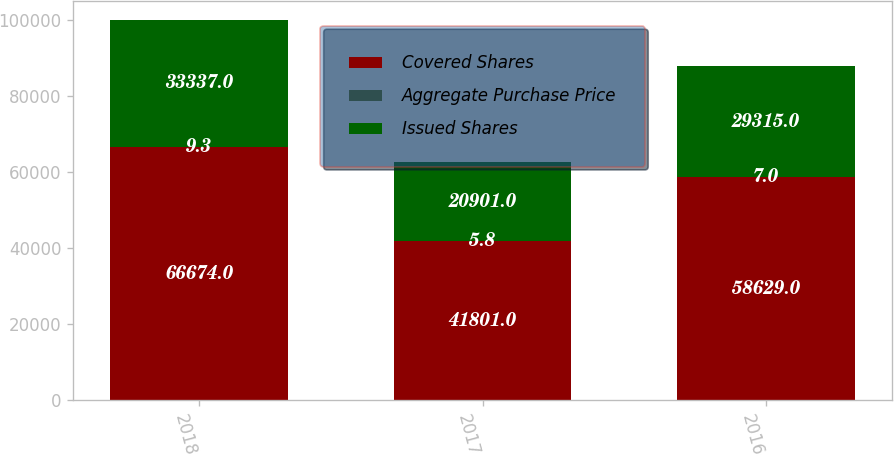Convert chart to OTSL. <chart><loc_0><loc_0><loc_500><loc_500><stacked_bar_chart><ecel><fcel>2018<fcel>2017<fcel>2016<nl><fcel>Covered Shares<fcel>66674<fcel>41801<fcel>58629<nl><fcel>Aggregate Purchase Price<fcel>9.3<fcel>5.8<fcel>7<nl><fcel>Issued Shares<fcel>33337<fcel>20901<fcel>29315<nl></chart> 